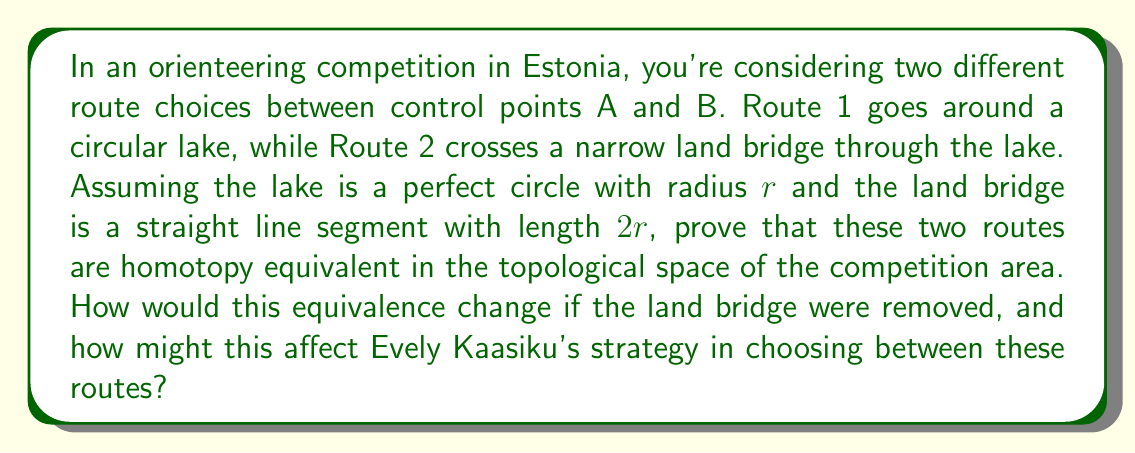Could you help me with this problem? To prove that the two routes are homotopy equivalent, we need to show that there exists a continuous deformation from one route to the other within the topological space of the competition area. Let's approach this step-by-step:

1. Define the topological space:
   Let $X$ be the topological space representing the competition area, including the lake and the land bridge.

2. Define the two routes:
   - Route 1: $f : [0,1] \to X$, representing the path around the lake
   - Route 2: $g : [0,1] \to X$, representing the path across the land bridge

3. Construct a homotopy:
   We need to find a continuous function $H : [0,1] \times [0,1] \to X$ such that:
   $$H(s,0) = f(s)$$ and $$H(s,1) = g(s)$$ for all $s \in [0,1]$

   We can define $H$ as follows:
   $$H(s,t) = (1-t)f(s) + tg(s)$$

   This function continuously deforms Route 1 into Route 2 as $t$ varies from 0 to 1.

4. Verify continuity:
   $H$ is continuous because it's a linear combination of two continuous functions.

5. Verify endpoints:
   $H(0,t) = A$ and $H(1,t) = B$ for all $t \in [0,1]$, ensuring that the endpoints remain fixed during the deformation.

Thus, we have shown that Routes 1 and 2 are homotopy equivalent.

If the land bridge were removed:
- The topological space would change, creating a "hole" (the lake) in the competition area.
- Routes 1 and 2 would no longer be homotopy equivalent, as it would be impossible to continuously deform one into the other without crossing the lake.
- This change creates two distinct homotopy classes of paths between A and B.

Impact on Evely Kaasiku's strategy:
- With the land bridge, Evely could choose either route based on factors like terrain and distance, knowing they are topologically equivalent.
- Without the land bridge, the choice becomes more critical:
  1. Route 1 (around the lake) is guaranteed to be valid but potentially longer.
  2. Route 2 (across the former land bridge) is no longer possible.
- Evely would need to carefully consider the trade-off between the longer but safe Route 1 and any potential shortcuts that don't cross the lake.
Answer: The two routes are homotopy equivalent when the land bridge is present. If the land bridge were removed, the routes would no longer be homotopy equivalent, creating two distinct homotopy classes of paths between A and B. This would significantly impact route choice strategy in the competition. 